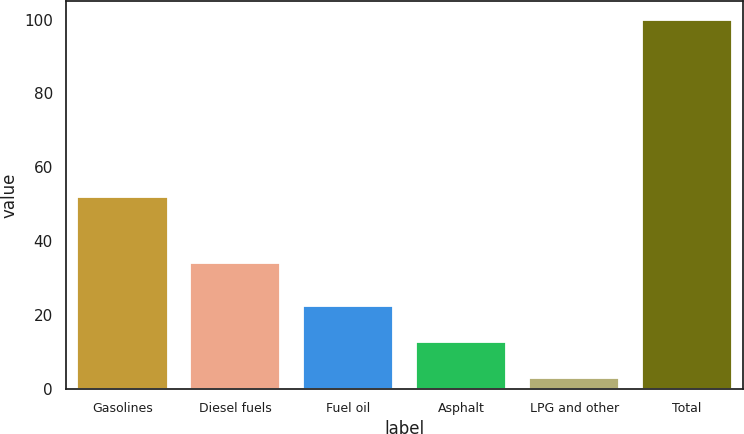Convert chart. <chart><loc_0><loc_0><loc_500><loc_500><bar_chart><fcel>Gasolines<fcel>Diesel fuels<fcel>Fuel oil<fcel>Asphalt<fcel>LPG and other<fcel>Total<nl><fcel>52<fcel>34<fcel>22.4<fcel>12.7<fcel>3<fcel>100<nl></chart> 